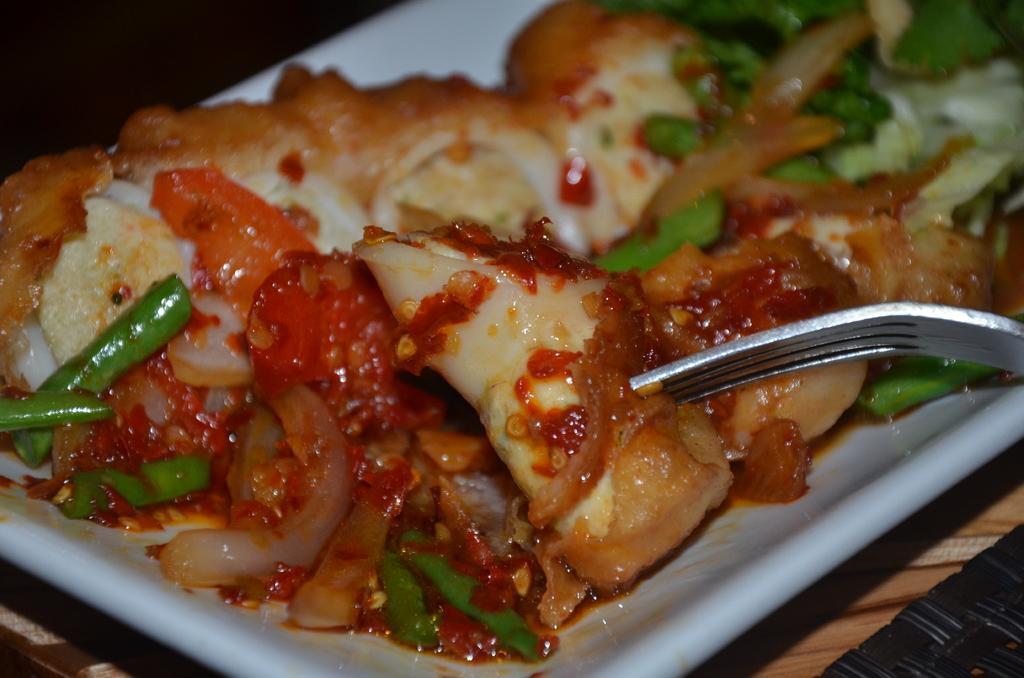Can you describe this image briefly? In this image, we can see a white color plate, in that plate there is some food, there is a fork kept in the plate. 